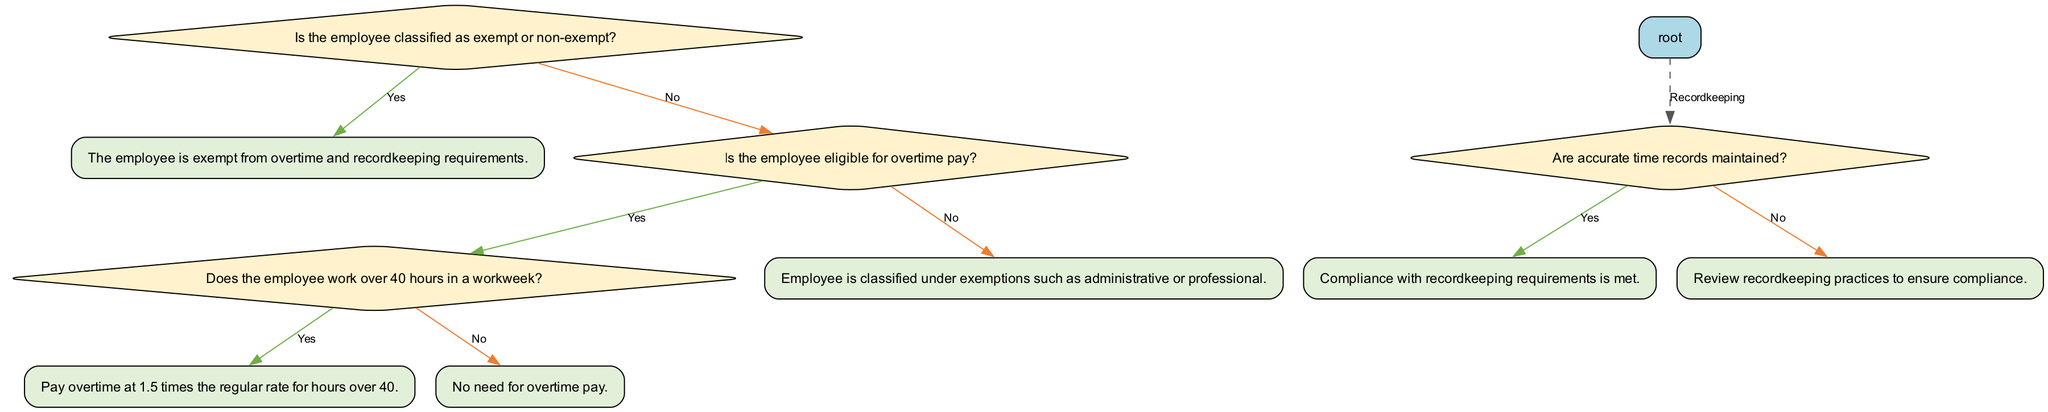What is the starting question in the decision tree? The decision tree begins with the question, "Is the employee classified as exempt or non-exempt?" which is the initial decision point for determining wage and hour compliance.
Answer: Is the employee classified as exempt or non-exempt? What happens if the employee is classified as exempt? If the employee is classified as exempt, the outcome states, "The employee is exempt from overtime and recordkeeping requirements." This conclusion is reached without further questions.
Answer: The employee is exempt from overtime and recordkeeping requirements What is the next question if the employee is non-exempt? If the employee is classified as non-exempt, the next question is "Is the employee eligible for overtime pay?" This node directs the process for determining further obligations.
Answer: Is the employee eligible for overtime pay? How many times is the question about overtime eligibility asked in the diagram? The question "Is the employee eligible for overtime pay?" is asked once in the diagram, specifically when evaluating a non-exempt employee's status.
Answer: 1 What do we need to consider if the employee is eligible for overtime pay? If the employee is eligible for overtime pay, we must consider whether the employee works over 40 hours in a workweek. This determines the applicable rate for paid overtime.
Answer: Whether the employee works over 40 hours in a workweek What is the outcome if the employee works over 40 hours in a workweek? If the employee works over 40 hours in a workweek, the required outcome is to "Pay overtime at 1.5 times the regular rate for hours over 40," which outlines the correct compensation method.
Answer: Pay overtime at 1.5 times the regular rate for hours over 40 What should be reviewed if accurate time records are not maintained? If accurate time records are not maintained, the outcome is to "Review recordkeeping practices to ensure compliance," which emphasizes the importance of proper recordkeeping to adhere to regulations.
Answer: Review recordkeeping practices to ensure compliance What is the relationship between recordkeeping and compliance? The relationship is that maintaining accurate time records directly ensures compliance with recordkeeping requirements, as indicated in the pathway leading to compliance.
Answer: Compliance with recordkeeping requirements is met Which section of the diagram contains a dashed line? The section concerning "Recordkeeping Requirements" contains a dashed line that connects this part of the diagram to the rest of the decision tree, indicating a separate but related consideration.
Answer: Recordkeeping Requirements 